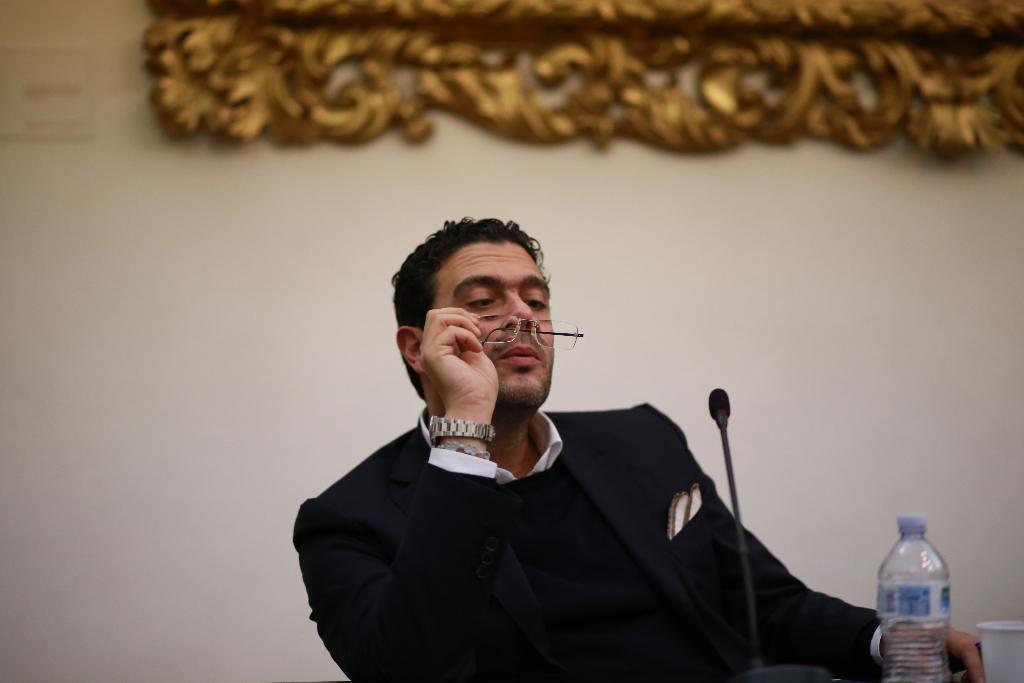How would you summarize this image in a sentence or two? In this picture a person is sitting and holding glasses in his hand. This person is wearing a suit and watch in his hand. Before him there is a milk, bottle and cup. 